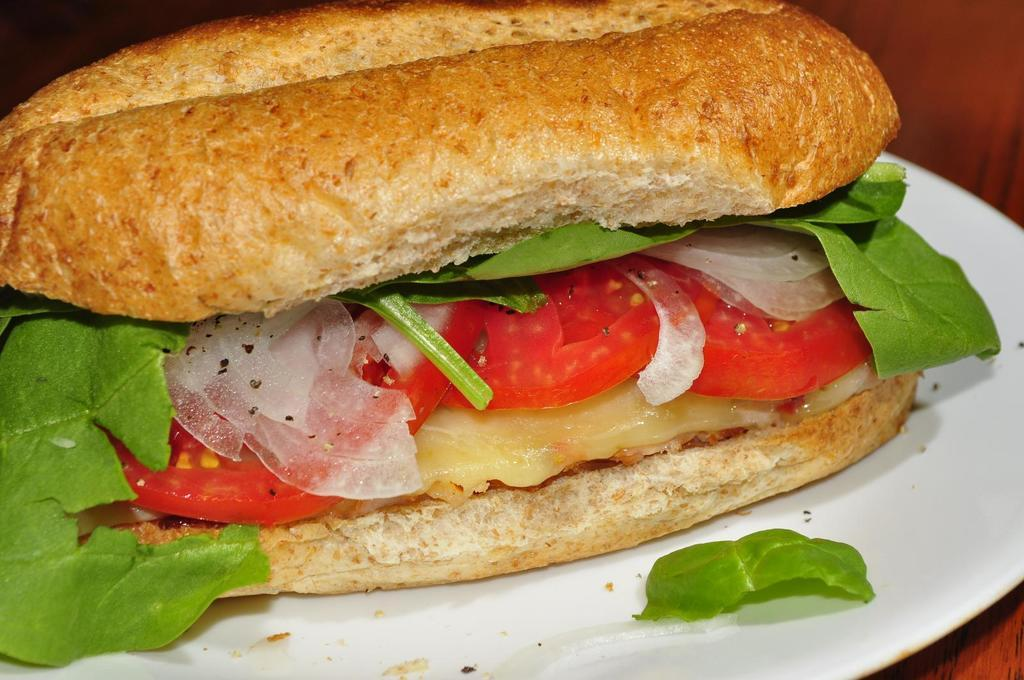What type of food can be seen in the image? The image contains food, but the specific type cannot be determined from the provided facts. What colors are present in the food? The food has brown, red, and green colors. What color is the plate on which the food is served? The plate is white. What line of text is written below the food in the image? There is no line of text or caption present below the food in the image. How does the food appear to be burned in the image? The food does not appear to be burned in the image; there is no indication of burning or any other damage. 